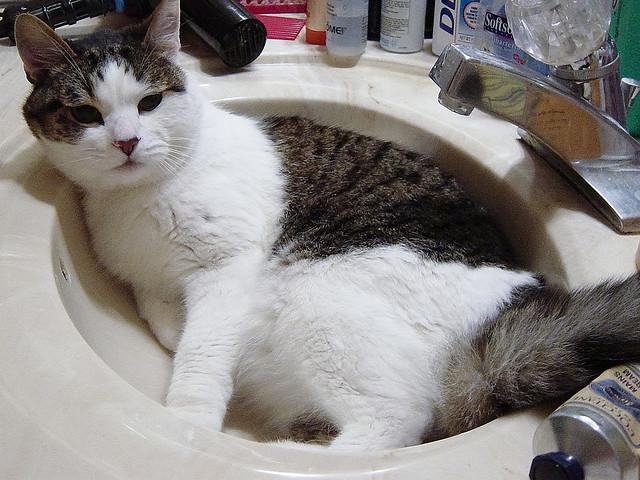What breed of cat is this?
Write a very short answer. American shorthair. Is the cat taking a bath?
Quick response, please. No. What object is in the picture?
Write a very short answer. Cat. Is the water running?
Answer briefly. No. 